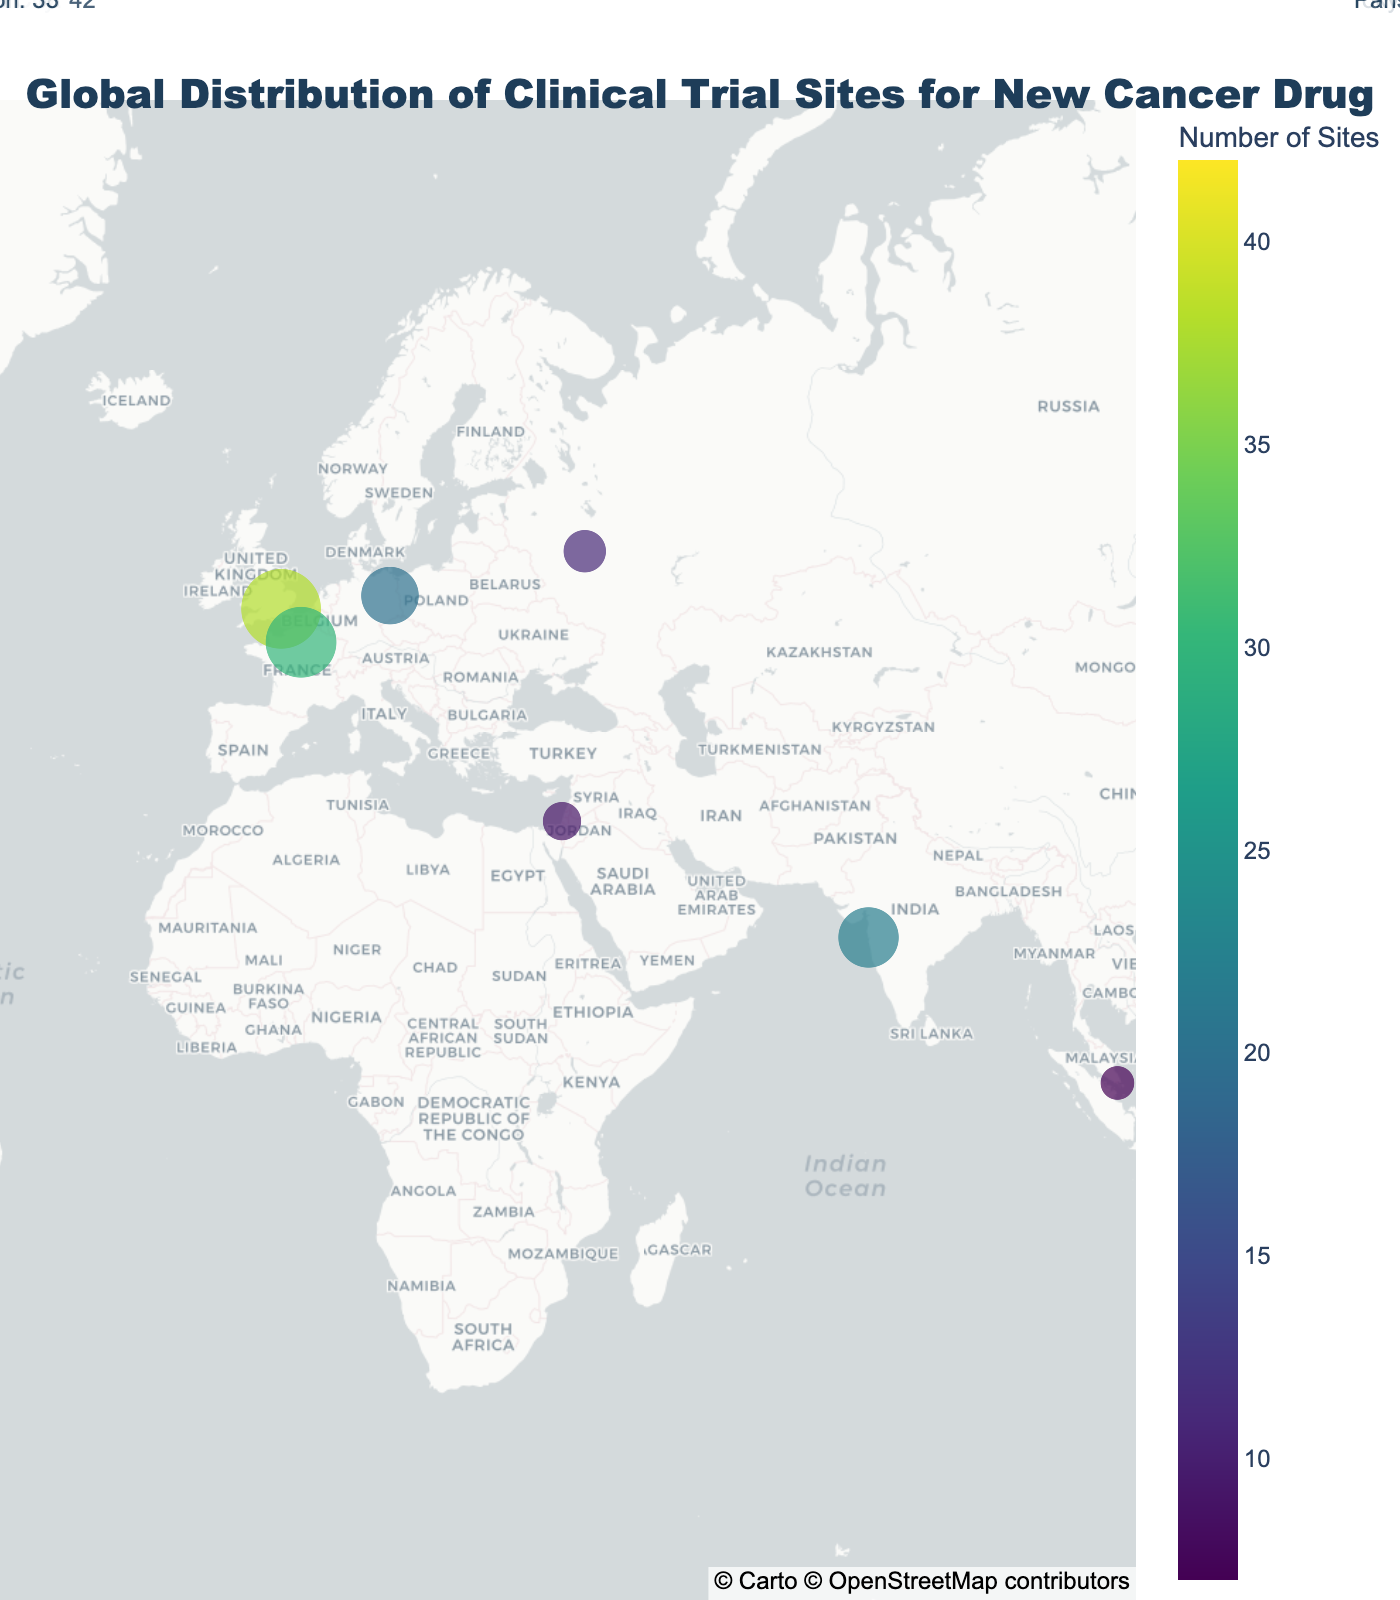What is the title of the figure? The title is always positioned at the top of the plot and typically summarizes the entire plot's nature. Here, it reads "Global Distribution of Clinical Trial Sites for New Cancer Drug".
Answer: Global Distribution of Clinical Trial Sites for New Cancer Drug Which city has the highest number of clinical trial sites? To find this information, locate the largest circle on the map and check its label. The largest circle is in New York City.
Answer: New York City What are the top three cities with the most clinical trial sites? Identify the three largest circles on the map and read their labels. They are New York City, London, and Tokyo.
Answer: New York City, London, Tokyo How many clinical trial sites are there in total in the USA? Sum the number of sites in New York City and Boston, which are the two cities in the USA. New York City has 42 sites and Boston has 33 sites. 42 + 33 = 75
Answer: 75 Which country has the second highest number of clinical trial sites? First, identify the countries of the top cities in the figure. The USA has the most sites (New York City and Boston). The UK (London) is the country with the second highest number of sites.
Answer: UK Is there a higher concentration of clinical trial sites in Europe or Asia? Compare the number of larger circles in Europe and Asia. Europe has cities like London, Paris, Berlin, and Moscow; Asia has Tokyo, Shanghai, Mumbai, and Seoul. Both have notable concentrations, but Asia has slightly more total sites.
Answer: Asia Which city in South America has clinical trial sites, and how many? Look for the circle located in South America. São Paulo in Brazil has clinical trial sites, with 13 in total.
Answer: São Paulo, 13 Compare the number of clinical trial sites between Paris and Berlin. Which has more, and by how many? Locate the circles for Paris and Berlin. Paris has 30 sites and Berlin has 20. Paris has more by 30 - 20 = 10 sites.
Answer: Paris, by 10 What is the average number of clinical trial sites for the cities shown on the plot? Sum the number of sites for all cities and divide by the number of cities. \( (42 + 38 + 35 + 33 + 30 + 28 + 25 + 22 + 20 + 18 + 15 + 13 + 11 + 9 + 7) = 346 \). There are 15 cities, so \( \frac{346}{15} \approx 23.07 \).
Answer: 23.07 Which city has fewer sites, Moscow or Tel Aviv, and by how many? Look at the circles for Moscow and Tel Aviv. Moscow has 11 sites, Tel Aviv has 9. Moscow has more by 11 - 9 = 2 sites.
Answer: Tel Aviv, by 2 